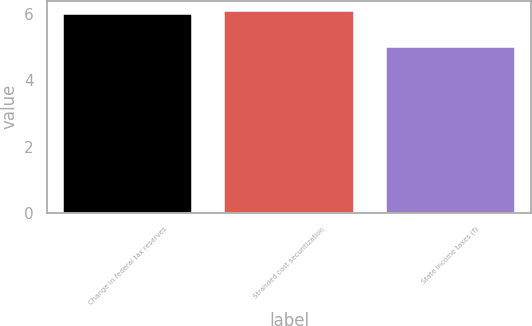<chart> <loc_0><loc_0><loc_500><loc_500><bar_chart><fcel>Change in federal tax reserves<fcel>Stranded cost securitization<fcel>State income taxes (f)<nl><fcel>6<fcel>6.1<fcel>5<nl></chart> 